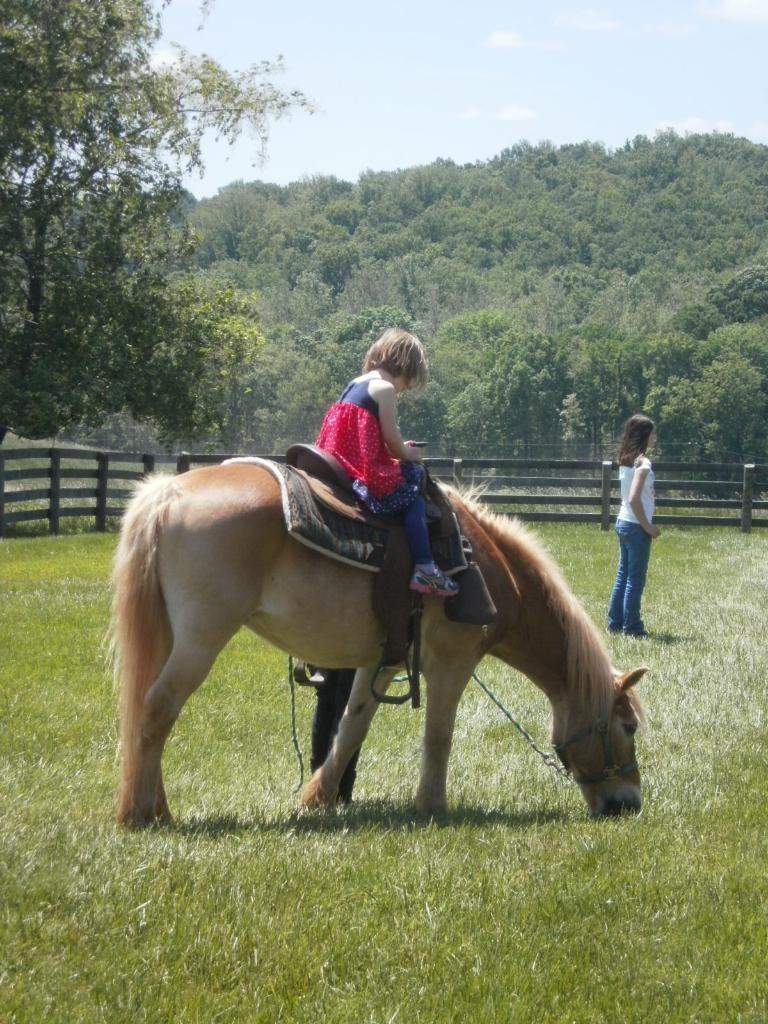What is the girl doing in the image? The girl is seated on a horse in the image. Who is near the horse in the image? There is a woman standing near the horse in the image. What can be seen in the background of the image? There are trees and a wooden fence in the background of the image. What type of company is the girl rewarded with in the image? There is no company or reward present in the image; it features a girl seated on a horse and a woman standing near the horse. What kind of cheese is visible on the horse in the image? There is no cheese present in the image; it only features a girl seated on a horse and a woman standing near the horse. 